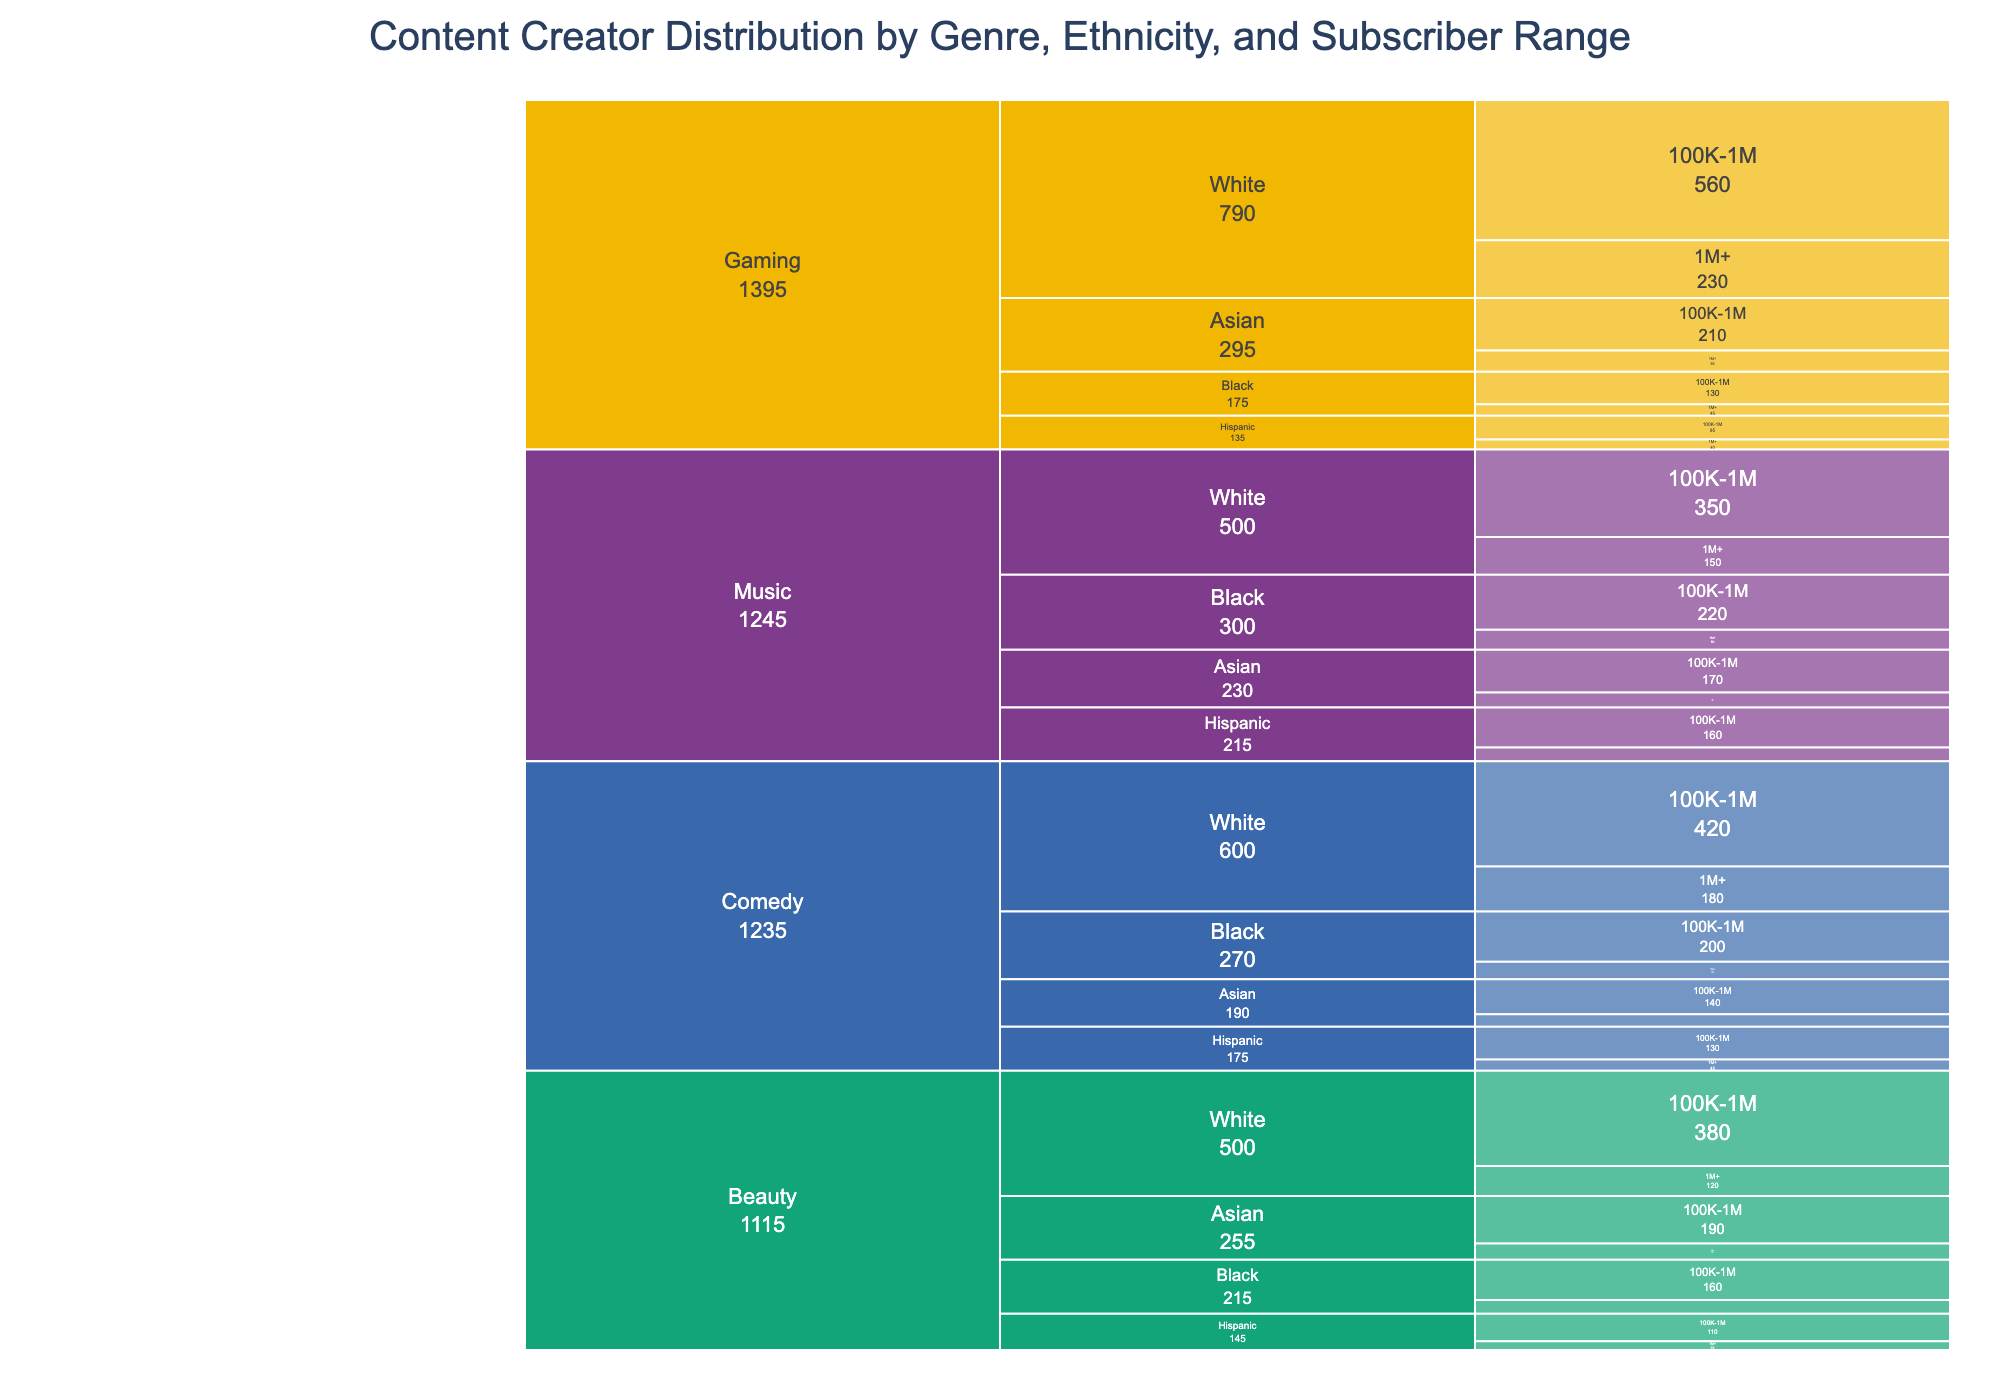what’s the title of the figure? The title of the figure is usually located at the top of the chart, written in a larger font size to distinguish it as the main heading. The title reads "Content Creator Distribution by Genre, Ethnicity, and Subscriber Range".
Answer: Content Creator Distribution by Genre, Ethnicity, and Subscriber Range What genre has the highest number of content creators with subscriber counts between 100K-1M? To answer this, identify the genres and their associated values. Gaming has unlabelled trunk lines and has 560, 210, 130, and 95 content creators (in descending order). The highest total number of content creators in this genre is 56+210+130+095.
Answer: Gaming Which ethnicity within the Comedy genre has the highest number of content creators in the 1M+ subscriber range? Scan the Comedy branches to locate each ethnicity's values for the 1M+ subscriber range. Notice that "Black" ethnicity shows a high value in this range, consisting of 70 content creators, the highest within Comedy.
Answer: Black Which Genre has the least representation for the Black ethnicity within the 1M+ subscriber range? Follow the branches from each genre to locate Black's values. Note that "Gaming" has 45, "Beauty" has 55, "Comedy" has 70, and "Music" has 80. "Gaming" shows the least representation with 45 content creators.
Answer: Gaming Compare the number of Hispanic content creators in the 100K-1M subscriber range between the Music and Gaming genres. Which genre has more, and by how much? For the Hispanic ethnicity within the 100K-1M subscriber range, Music has 160 and Gaming has 95. Subtracting the values (160 - 95) reveals that Music has 65 more Hispanic content creators in this range.
Answer: Music, 65 more In the Beauty genre, which subscriber range has a larger number of Asian content creators, and how much larger is it compared to the other range? Look at the Beauty branches and find the Asian values. In the 1M+ range, there are 65, and in the 100K-1M range, there are 190. Subtracting (190 - 65) shows that the 100K-1M range is larger by 125 content creators.
Answer: 100K-1M, 125 more How many total content creators are there within the Gaming genre? Sum the values of all sub-branches under Gaming. Add up White (230 + 560), Asian (85 + 210), Black (45 + 130), and Hispanic (40 + 95). This gives a total calculation as 1700 to confirm.
Answer: 1,170 Which genre has the highest number of total content creators? Track up each genre and sum their total content creator values. Gaming's value (1,085) surpasses all others—Beauty (780), Comedy (735), and Music (755). Thus, Gaming has the highest number.
Answer: Gaming 